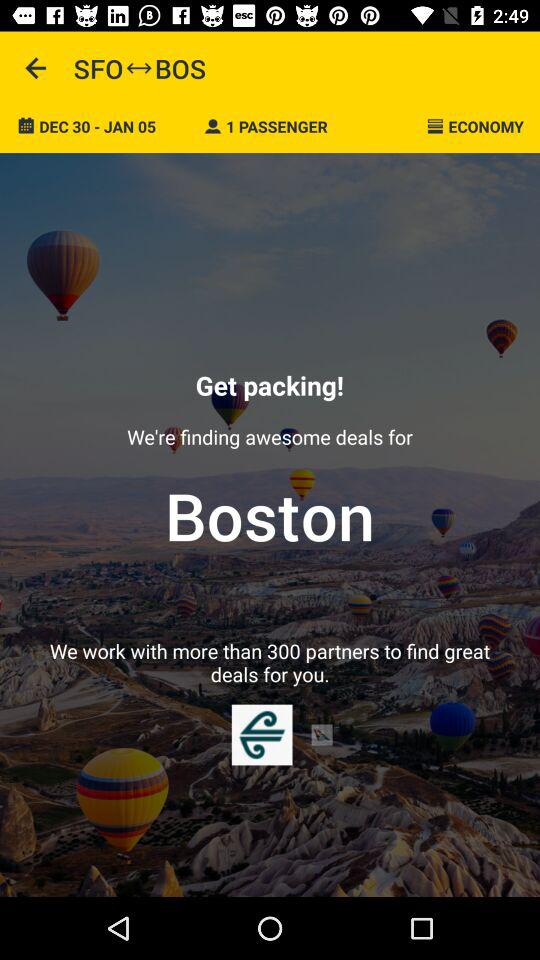What is the date range shown on the screen? The date range shown on the screen is December 30 to January 5. 